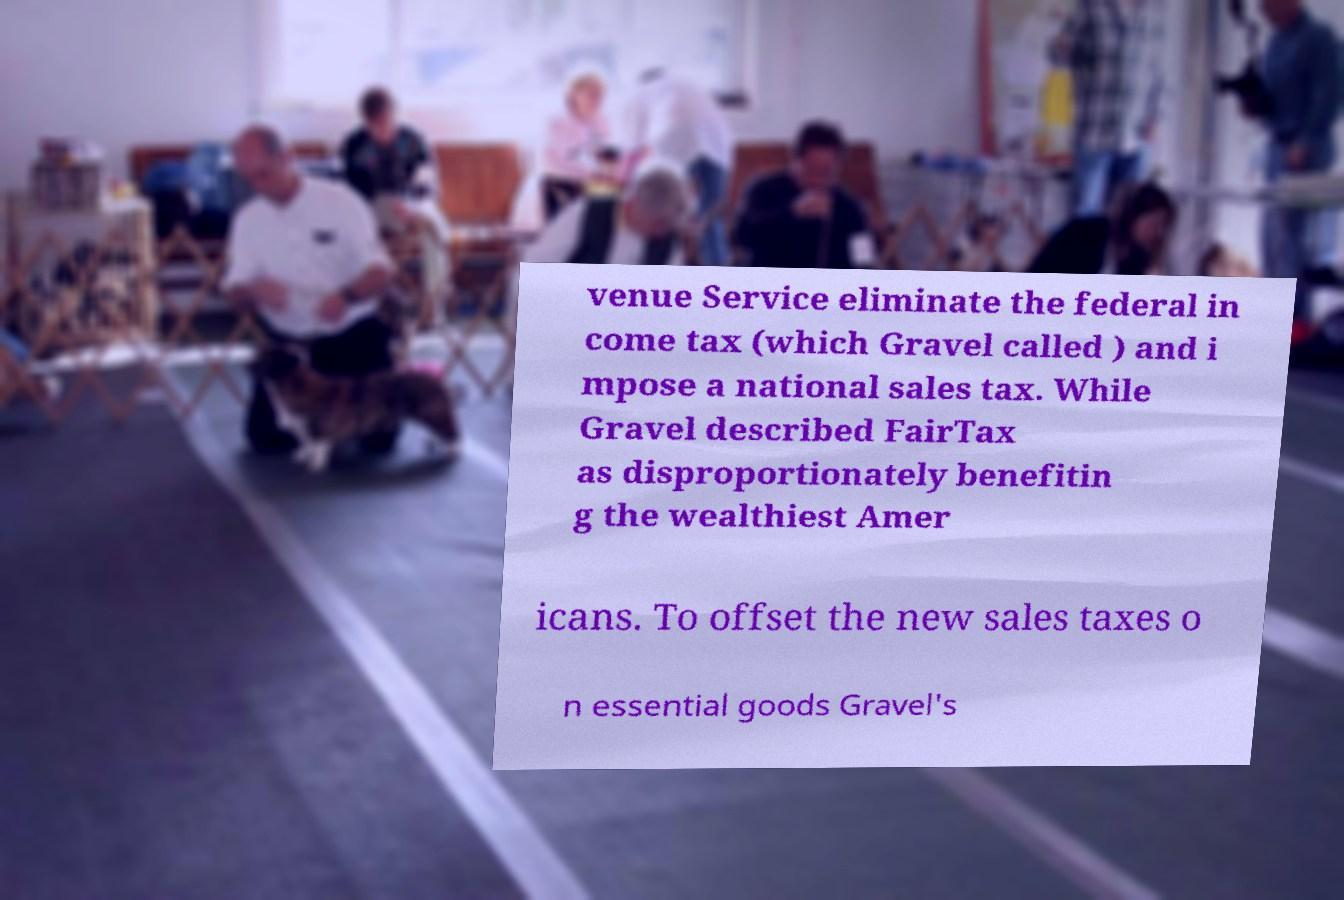I need the written content from this picture converted into text. Can you do that? venue Service eliminate the federal in come tax (which Gravel called ) and i mpose a national sales tax. While Gravel described FairTax as disproportionately benefitin g the wealthiest Amer icans. To offset the new sales taxes o n essential goods Gravel's 